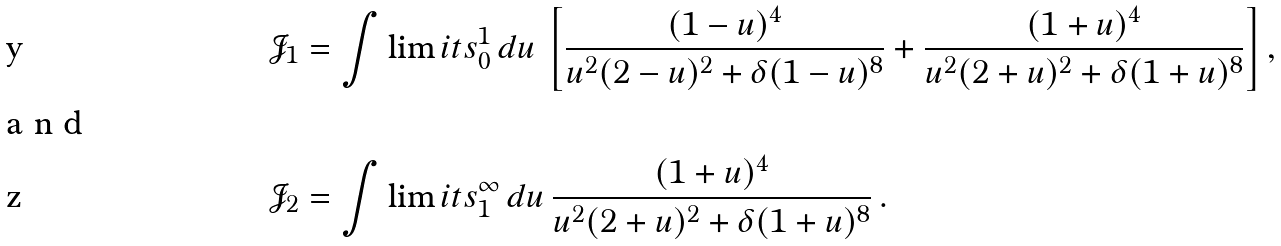Convert formula to latex. <formula><loc_0><loc_0><loc_500><loc_500>\mathcal { J } _ { 1 } & = \int \lim i t s _ { 0 } ^ { 1 } \, d u \, \left [ \frac { ( 1 - u ) ^ { 4 } } { u ^ { 2 } ( 2 - u ) ^ { 2 } + \delta ( 1 - u ) ^ { 8 } } + \frac { ( 1 + u ) ^ { 4 } } { u ^ { 2 } ( 2 + u ) ^ { 2 } + \delta ( 1 + u ) ^ { 8 } } \right ] , \\ \intertext { a n d } \mathcal { J } _ { 2 } & = \int \lim i t s _ { 1 } ^ { \infty } \, d u \, \frac { ( 1 + u ) ^ { 4 } } { u ^ { 2 } ( 2 + u ) ^ { 2 } + \delta ( 1 + u ) ^ { 8 } } \, .</formula> 